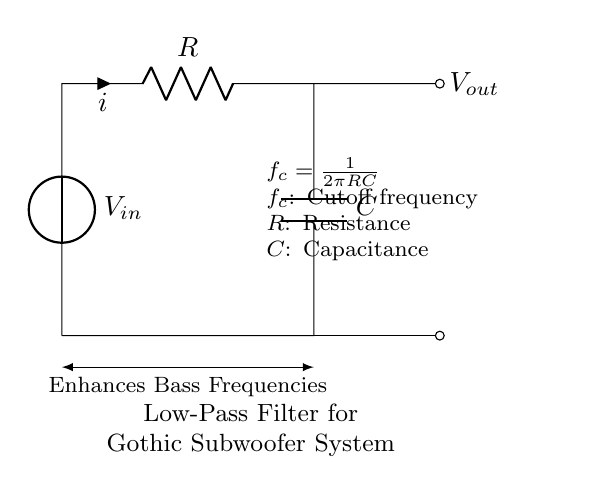What is the input voltage in the circuit? The input voltage is denoted as V_in, which is the voltage source connected at the top of the circuit diagram.
Answer: V_in What is the role of the resistor in this low-pass filter? The resistor, labeled R, limits the current flowing in the circuit and works together with the capacitor to determine the cutoff frequency of the filter.
Answer: To limit current What is the significance of the cutoff frequency equation provided? The equation given states that the cutoff frequency (f_c) is a function of the resistance (R) and capacitance (C). It shows how these components control the behavior of the low-pass filter.
Answer: Determines filter behavior What is the expected effect of this circuit on audio signals? The circuit enhances bass frequencies by allowing low frequencies to pass while attenuating higher frequencies, suitable for subwoofer applications.
Answer: Enhances bass How does increasing the capacitance affect the cutoff frequency? Increasing capacitance (C) decreases the cutoff frequency (f_c) according to the equation f_c = 1/(2πRC). This means more bass frequencies can pass through.
Answer: Decreases cutoff frequency What happens to the output voltage as the frequency increases? The output voltage (V_out) will decrease as frequency increases, due to the nature of the low-pass filter which attenuates higher frequencies.
Answer: Decreases Which component directly affects the cutoff frequency alongside the resistor? The capacitor (C) directly affects the cutoff frequency, working with the resistor (R) to determine the frequency at which signals begin to be attenuated.
Answer: Capacitor 